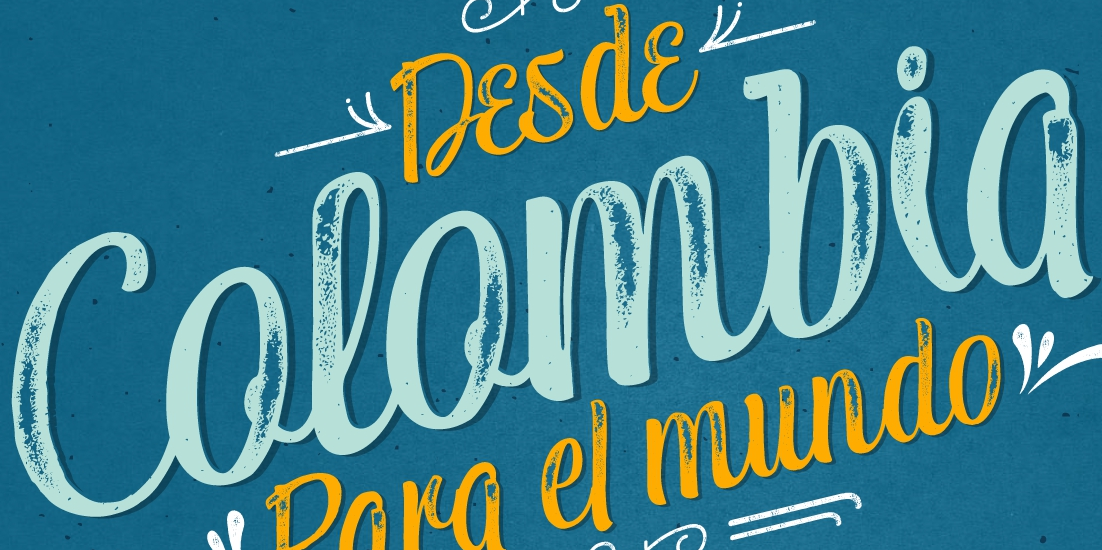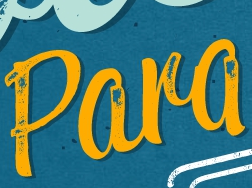Read the text content from these images in order, separated by a semicolon. Colombia; Para 